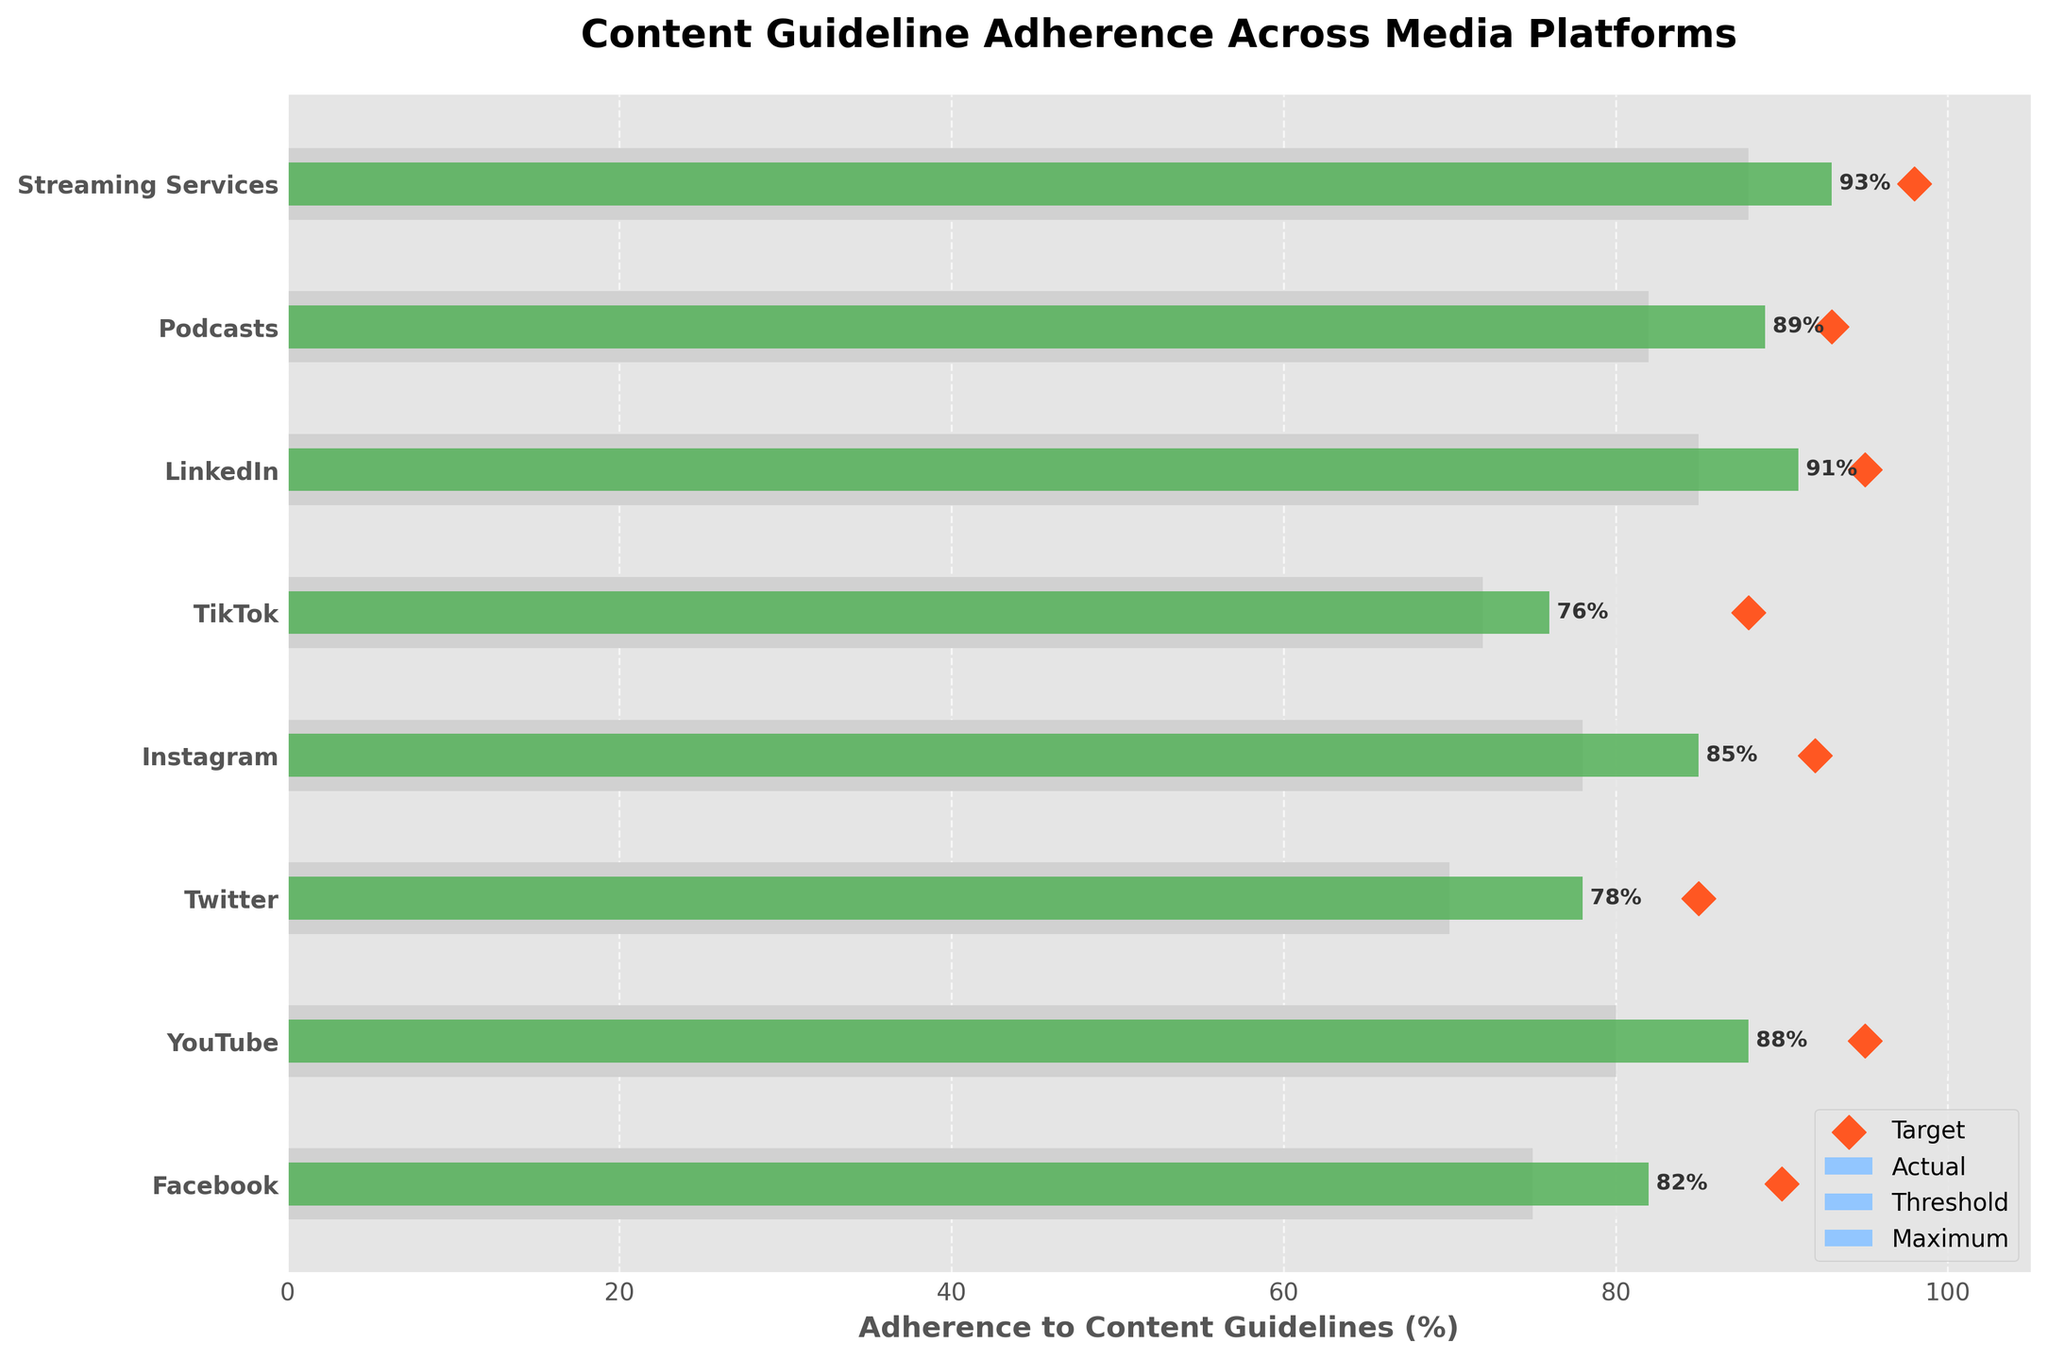What is the title of the figure? The title of the figure can be found at the top, typically providing a summary of the content. In this case, the title is clearly written at the top of the figure.
Answer: Content Guideline Adherence Across Media Platforms Which platform has the highest actual adherence to content guidelines? To find this, look at the bars and note the length/value of each. The longest bar represents the highest adherence.
Answer: Streaming Services What is the target adherence percentage for TikTok? Refer to the diamond-shaped marker on the horizontal axis line corresponding to TikTok. The position of this marker shows the target percentage.
Answer: 88% Which platform has the lowest actual adherence percentage? Compare the bars across all platforms to find the shortest one, which indicates the lowest adherence.
Answer: TikTok How does LinkedIn's actual adherence compare to the threshold? Determine the actual adherence percentage and compare it to the bar representing the threshold for LinkedIn. LinkedIn's actual adherence should be visually higher or lower than the threshold bar.
Answer: Higher How many platforms have actual adherence percentages exceeding the threshold? Count the number of bars that extend beyond the threshold representation across all platforms.
Answer: 8 Among Facebook, Instagram, and YouTube, which platform has the highest actual adherence? Compare the lengths of the bars for Facebook, Instagram, and YouTube. The longest bar among them indicates the highest adherence.
Answer: YouTube Is Twitter's actual adherence below its target but above its threshold? Check the position of the actual bar for Twitter and see if it lies between the threshold and target markers. Confirm this visually.
Answer: Yes What is the range of target adherence percentages across all platforms? To find the range, identify the minimum and maximum target adherence percentages and subtract the smallest from the largest. Here, minimum is 85% (Twitter) and maximum is 98% (Streaming Services).
Answer: 98% - 85% = 13% If the target adherence for YouTube increased by 3%, what would the new target be? Add 3% to YouTube's current target percentage. The current target is 95%, so the new target will be 95% + 3%.
Answer: 98% 